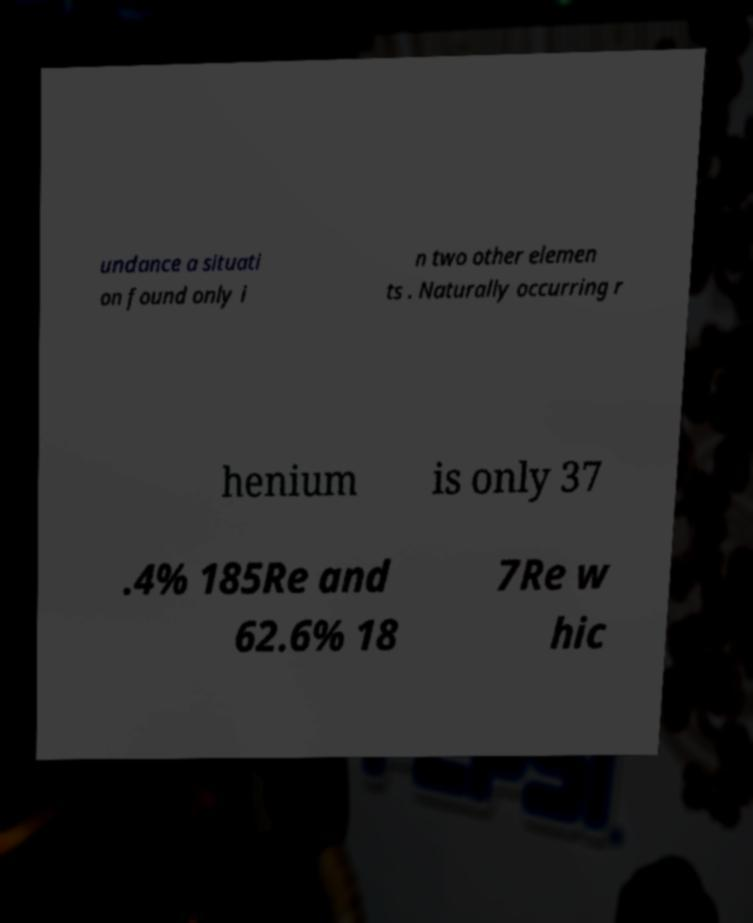Can you read and provide the text displayed in the image?This photo seems to have some interesting text. Can you extract and type it out for me? undance a situati on found only i n two other elemen ts . Naturally occurring r henium is only 37 .4% 185Re and 62.6% 18 7Re w hic 